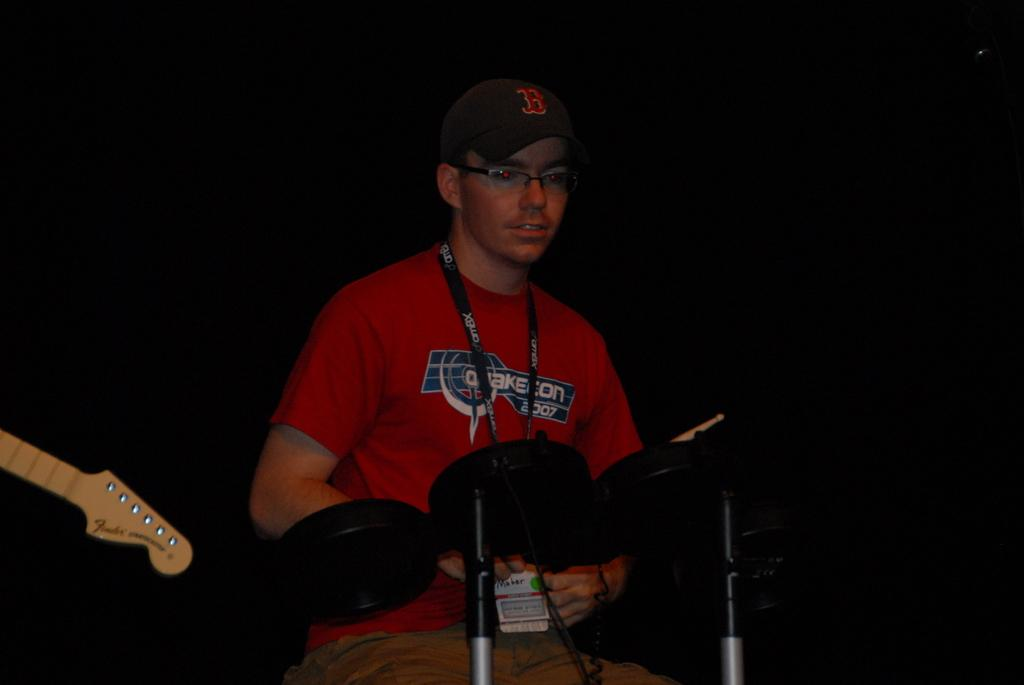What is the main subject of the image? The main subject of the image is a person. What is the person wearing in the image? The person is wearing a red t-shirt and a cap. What is the person doing in the image? The person is playing a musical instrument. What is the color of the background in the image? The background of the image is dark. What is the purpose of the goldfish in the image? There is no goldfish present in the image. Can you tell me how many coaches are visible in the image? There are no coaches present in the image. 